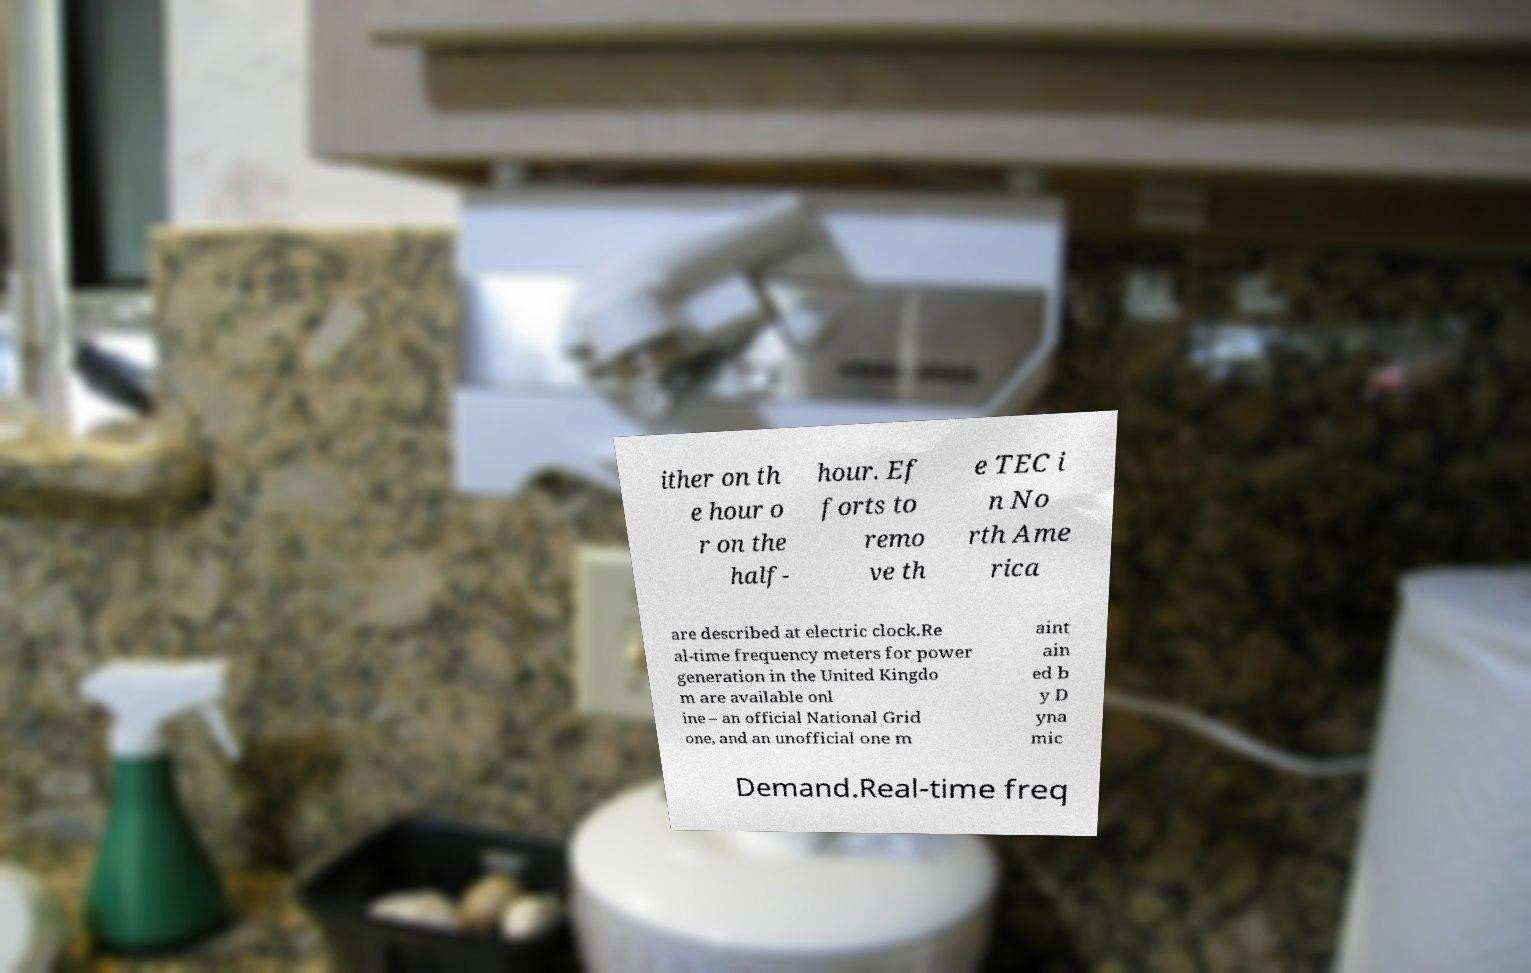I need the written content from this picture converted into text. Can you do that? ither on th e hour o r on the half- hour. Ef forts to remo ve th e TEC i n No rth Ame rica are described at electric clock.Re al-time frequency meters for power generation in the United Kingdo m are available onl ine – an official National Grid one, and an unofficial one m aint ain ed b y D yna mic Demand.Real-time freq 